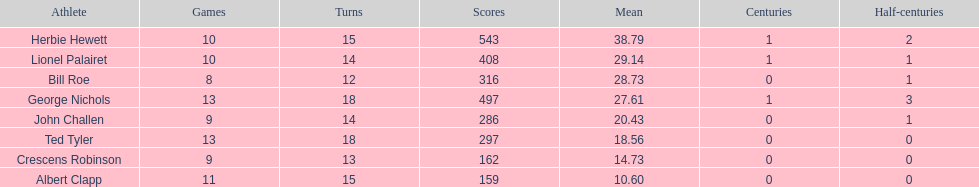How many players played more than 10 matches? 3. 